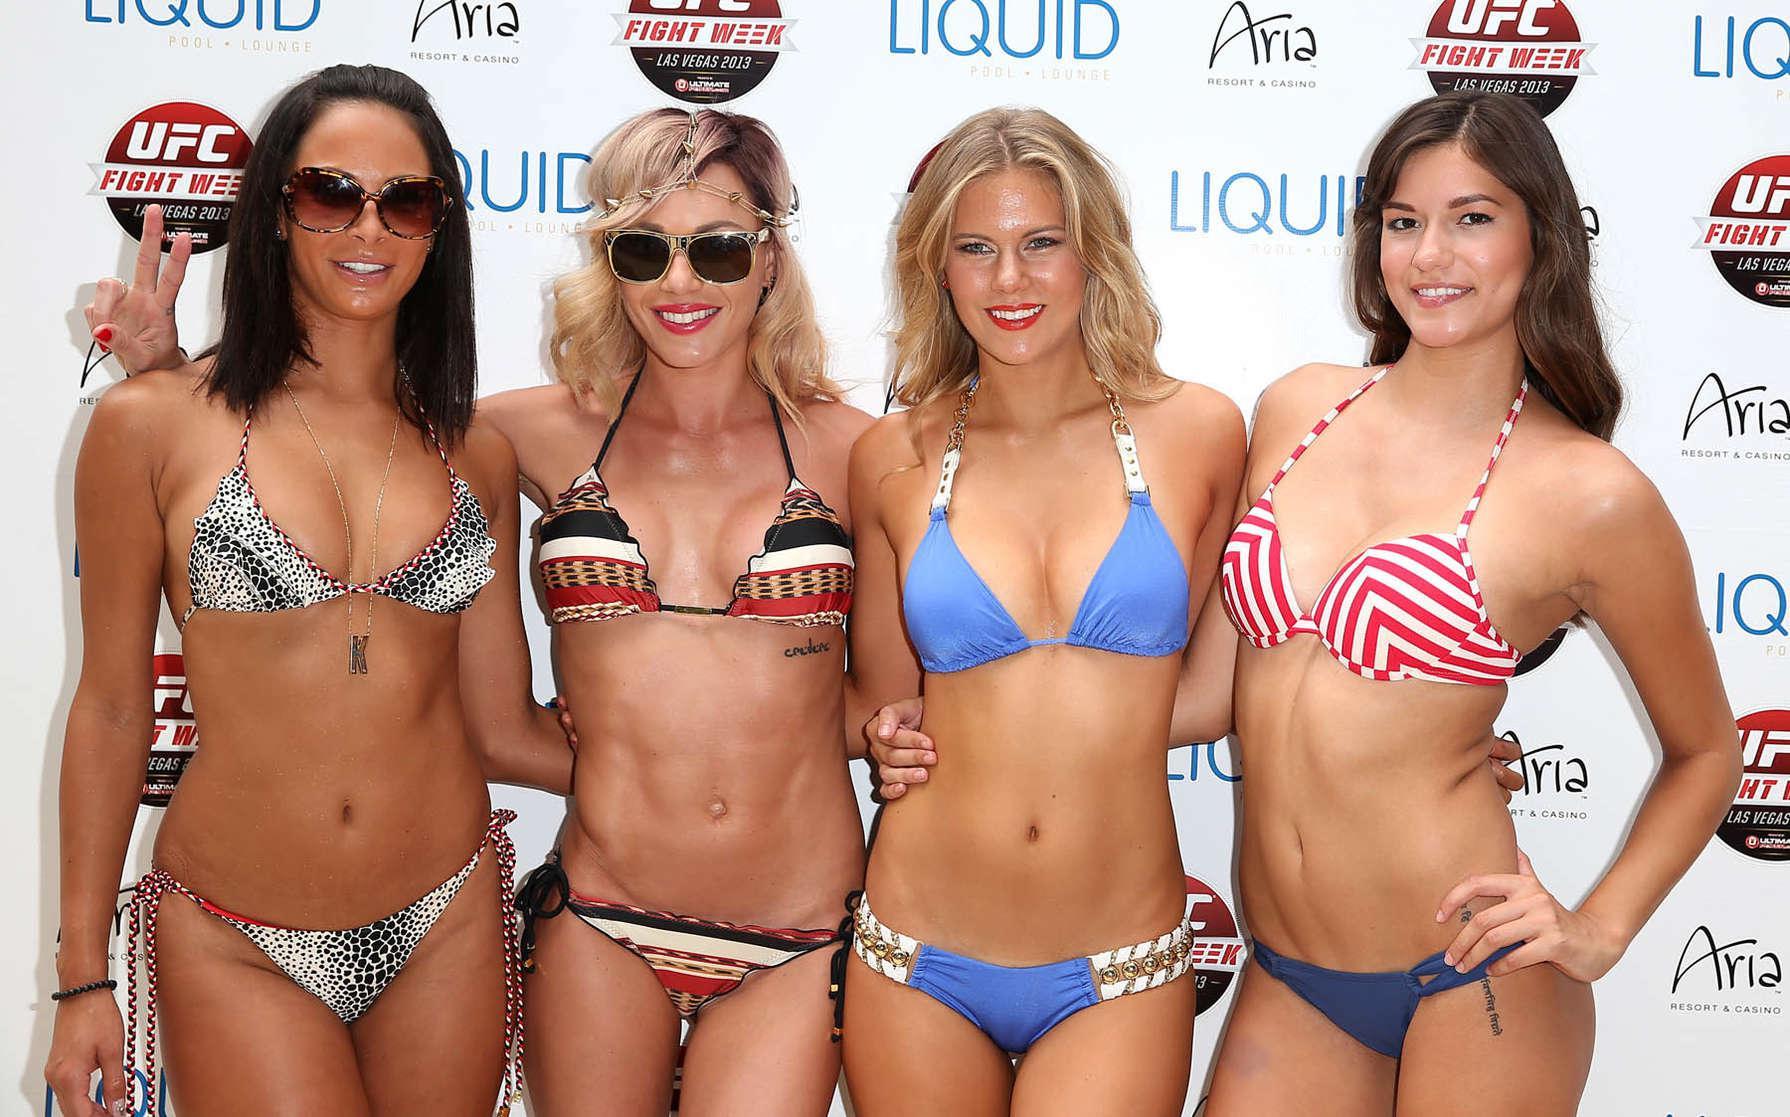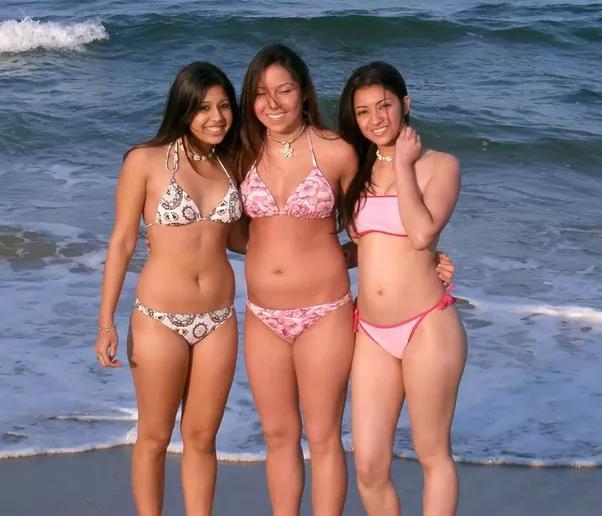The first image is the image on the left, the second image is the image on the right. For the images shown, is this caption "The right image has three women standing outside." true? Answer yes or no. Yes. The first image is the image on the left, the second image is the image on the right. Examine the images to the left and right. Is the description "There are three girls posing together in bikinis in the right image." accurate? Answer yes or no. Yes. 